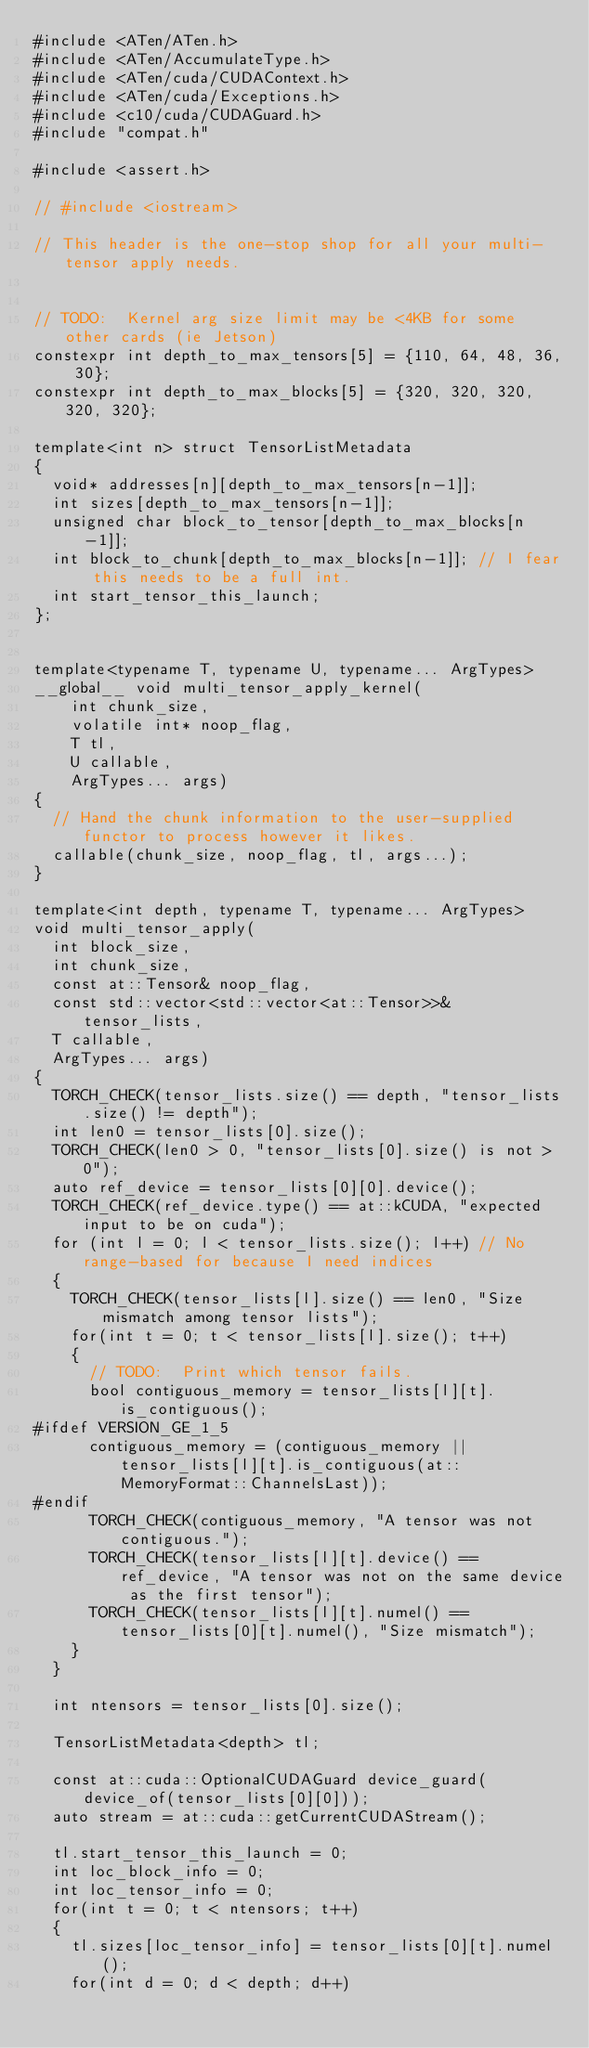Convert code to text. <code><loc_0><loc_0><loc_500><loc_500><_Cuda_>#include <ATen/ATen.h>
#include <ATen/AccumulateType.h>
#include <ATen/cuda/CUDAContext.h>
#include <ATen/cuda/Exceptions.h>
#include <c10/cuda/CUDAGuard.h>
#include "compat.h"

#include <assert.h>

// #include <iostream>

// This header is the one-stop shop for all your multi-tensor apply needs.


// TODO:  Kernel arg size limit may be <4KB for some other cards (ie Jetson)
constexpr int depth_to_max_tensors[5] = {110, 64, 48, 36, 30};
constexpr int depth_to_max_blocks[5] = {320, 320, 320, 320, 320};

template<int n> struct TensorListMetadata
{
  void* addresses[n][depth_to_max_tensors[n-1]];
  int sizes[depth_to_max_tensors[n-1]];
  unsigned char block_to_tensor[depth_to_max_blocks[n-1]];
  int block_to_chunk[depth_to_max_blocks[n-1]]; // I fear this needs to be a full int.
  int start_tensor_this_launch;
};


template<typename T, typename U, typename... ArgTypes>
__global__ void multi_tensor_apply_kernel(
    int chunk_size,
    volatile int* noop_flag,
    T tl,
    U callable,
    ArgTypes... args)
{
  // Hand the chunk information to the user-supplied functor to process however it likes.
  callable(chunk_size, noop_flag, tl, args...);
}

template<int depth, typename T, typename... ArgTypes>
void multi_tensor_apply(
  int block_size,
  int chunk_size,
  const at::Tensor& noop_flag,
  const std::vector<std::vector<at::Tensor>>& tensor_lists,
  T callable,
  ArgTypes... args)
{
  TORCH_CHECK(tensor_lists.size() == depth, "tensor_lists.size() != depth");
  int len0 = tensor_lists[0].size();
  TORCH_CHECK(len0 > 0, "tensor_lists[0].size() is not > 0");
  auto ref_device = tensor_lists[0][0].device();
  TORCH_CHECK(ref_device.type() == at::kCUDA, "expected input to be on cuda");
  for (int l = 0; l < tensor_lists.size(); l++) // No range-based for because I need indices
  {
    TORCH_CHECK(tensor_lists[l].size() == len0, "Size mismatch among tensor lists");
    for(int t = 0; t < tensor_lists[l].size(); t++)
    {
      // TODO:  Print which tensor fails.
      bool contiguous_memory = tensor_lists[l][t].is_contiguous();
#ifdef VERSION_GE_1_5
      contiguous_memory = (contiguous_memory || tensor_lists[l][t].is_contiguous(at::MemoryFormat::ChannelsLast));
#endif
      TORCH_CHECK(contiguous_memory, "A tensor was not contiguous.");
      TORCH_CHECK(tensor_lists[l][t].device() == ref_device, "A tensor was not on the same device as the first tensor");
      TORCH_CHECK(tensor_lists[l][t].numel() == tensor_lists[0][t].numel(), "Size mismatch");
    }
  }

  int ntensors = tensor_lists[0].size();

  TensorListMetadata<depth> tl;

  const at::cuda::OptionalCUDAGuard device_guard(device_of(tensor_lists[0][0]));
  auto stream = at::cuda::getCurrentCUDAStream();

  tl.start_tensor_this_launch = 0;
  int loc_block_info = 0;
  int loc_tensor_info = 0;
  for(int t = 0; t < ntensors; t++)
  {
    tl.sizes[loc_tensor_info] = tensor_lists[0][t].numel();
    for(int d = 0; d < depth; d++)</code> 